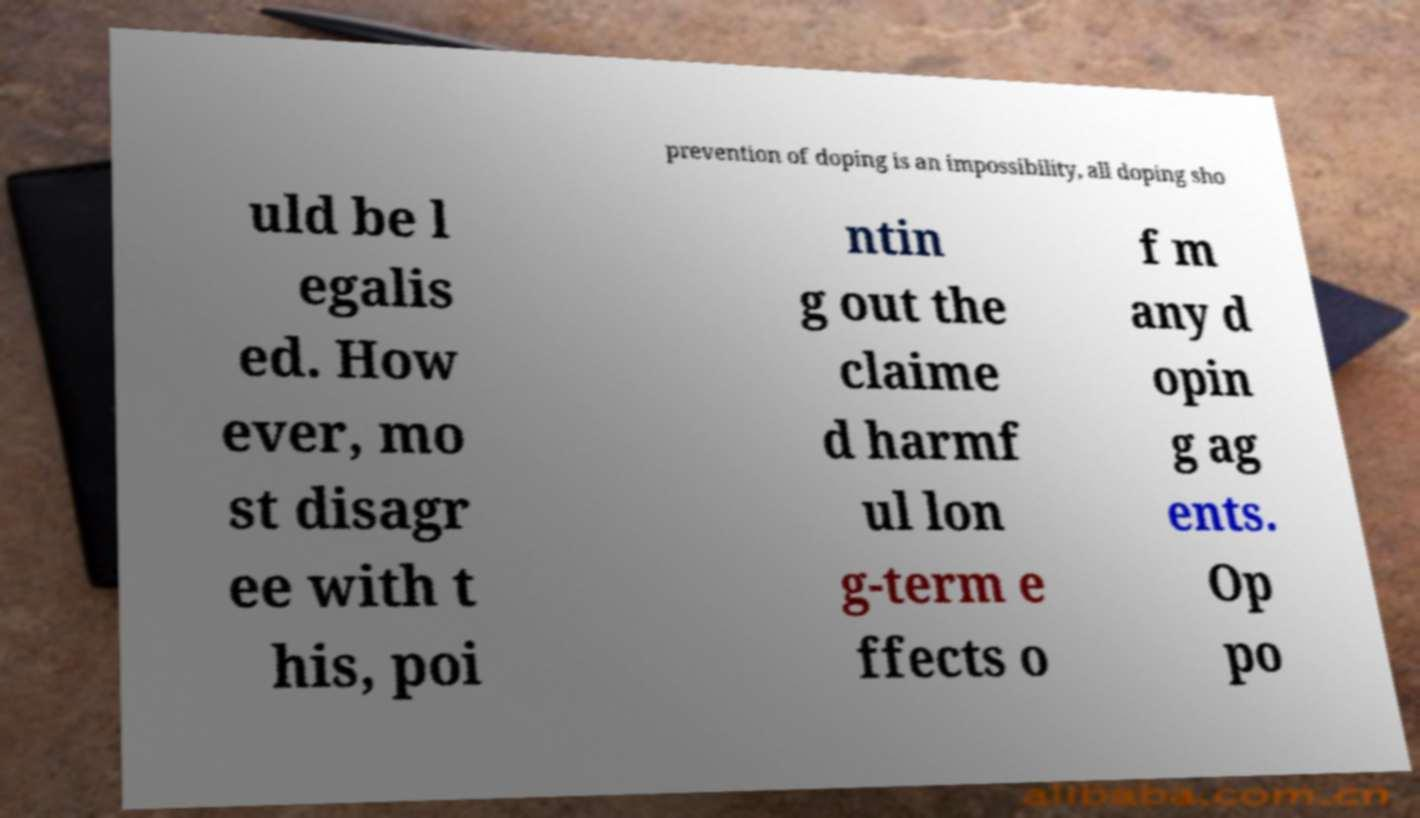There's text embedded in this image that I need extracted. Can you transcribe it verbatim? prevention of doping is an impossibility, all doping sho uld be l egalis ed. How ever, mo st disagr ee with t his, poi ntin g out the claime d harmf ul lon g-term e ffects o f m any d opin g ag ents. Op po 